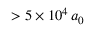<formula> <loc_0><loc_0><loc_500><loc_500>> 5 \times 1 0 ^ { 4 } \, a _ { 0 }</formula> 